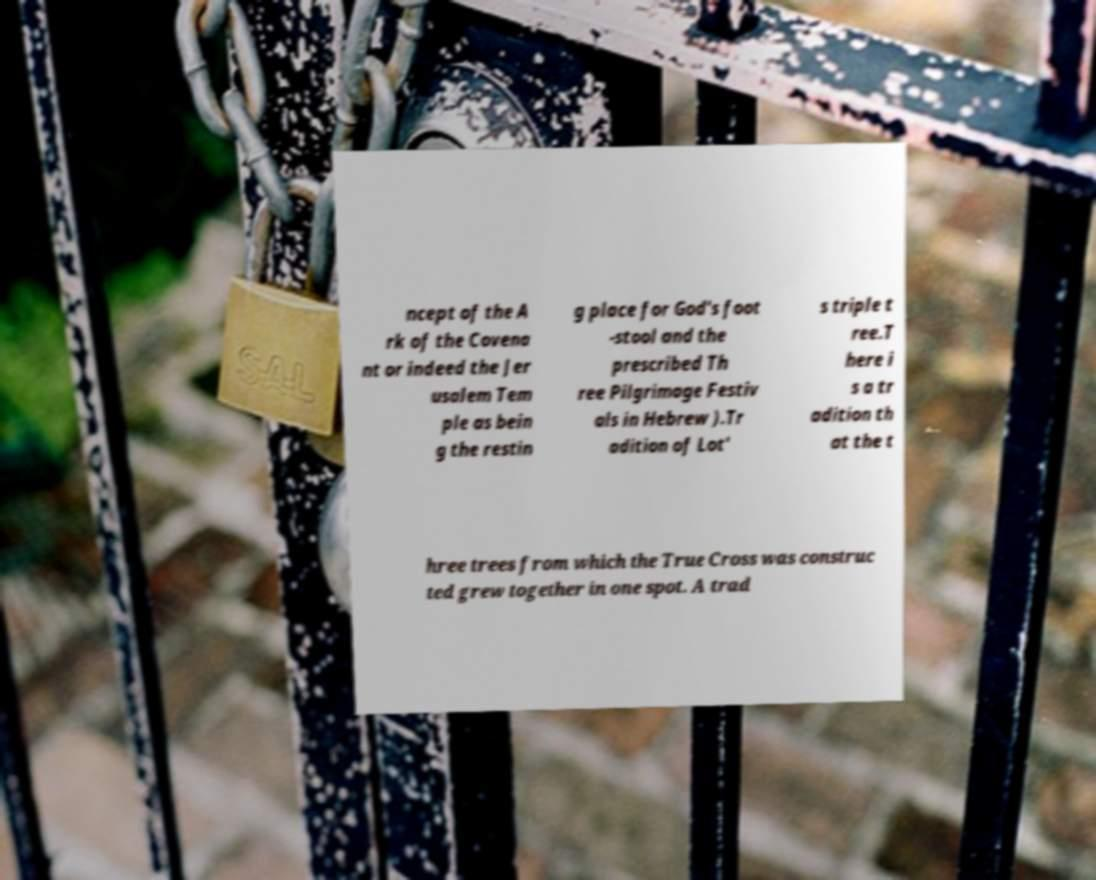There's text embedded in this image that I need extracted. Can you transcribe it verbatim? ncept of the A rk of the Covena nt or indeed the Jer usalem Tem ple as bein g the restin g place for God's foot -stool and the prescribed Th ree Pilgrimage Festiv als in Hebrew ).Tr adition of Lot' s triple t ree.T here i s a tr adition th at the t hree trees from which the True Cross was construc ted grew together in one spot. A trad 